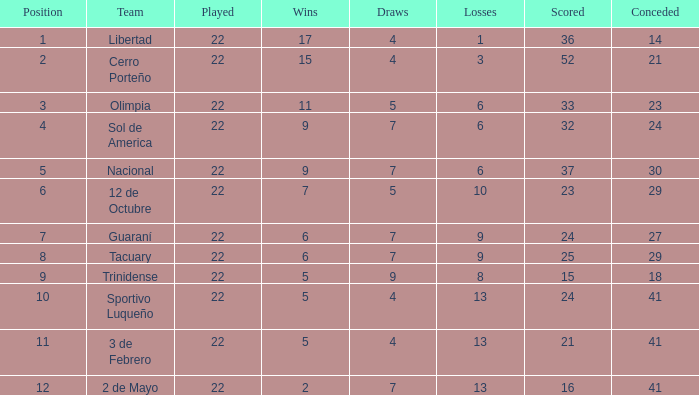What is the minimum victories with less than 23 goals scored, 2 de mayo team, and under 7 draws? None. 